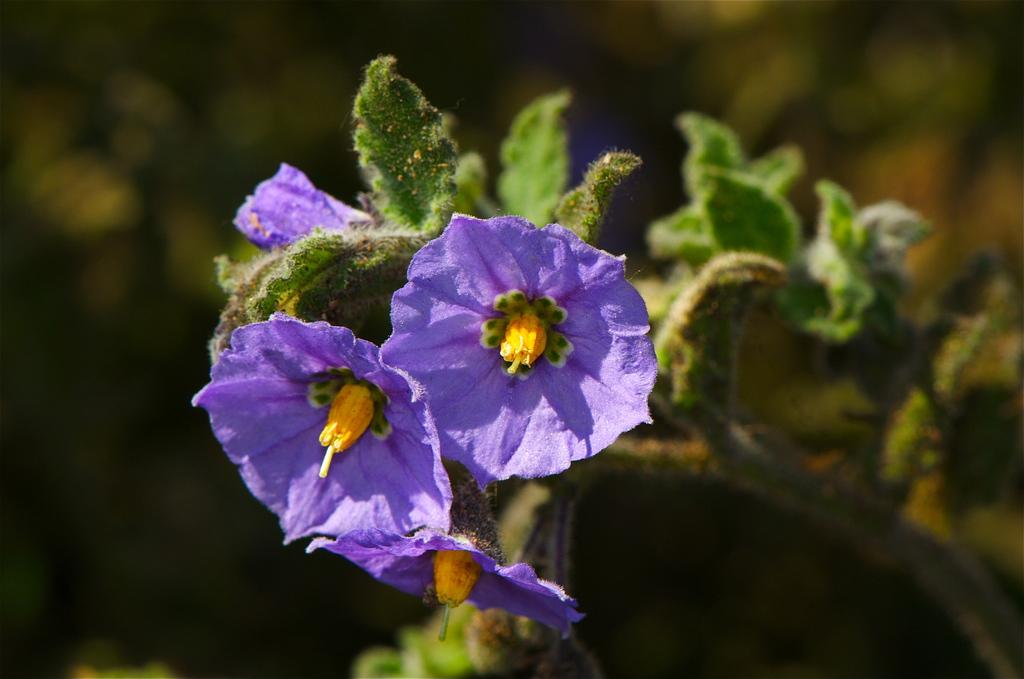What types of vegetation can be seen in the foreground of the image? There are flowers and plants in the foreground of the image. What types of vegetation can be seen in the background of the image? There are plants in the background of the image. What time of day is it in the image, and how does the night affect the motion of the plants? The time of day is not mentioned in the image, and there is no indication of night or motion of the plants. 